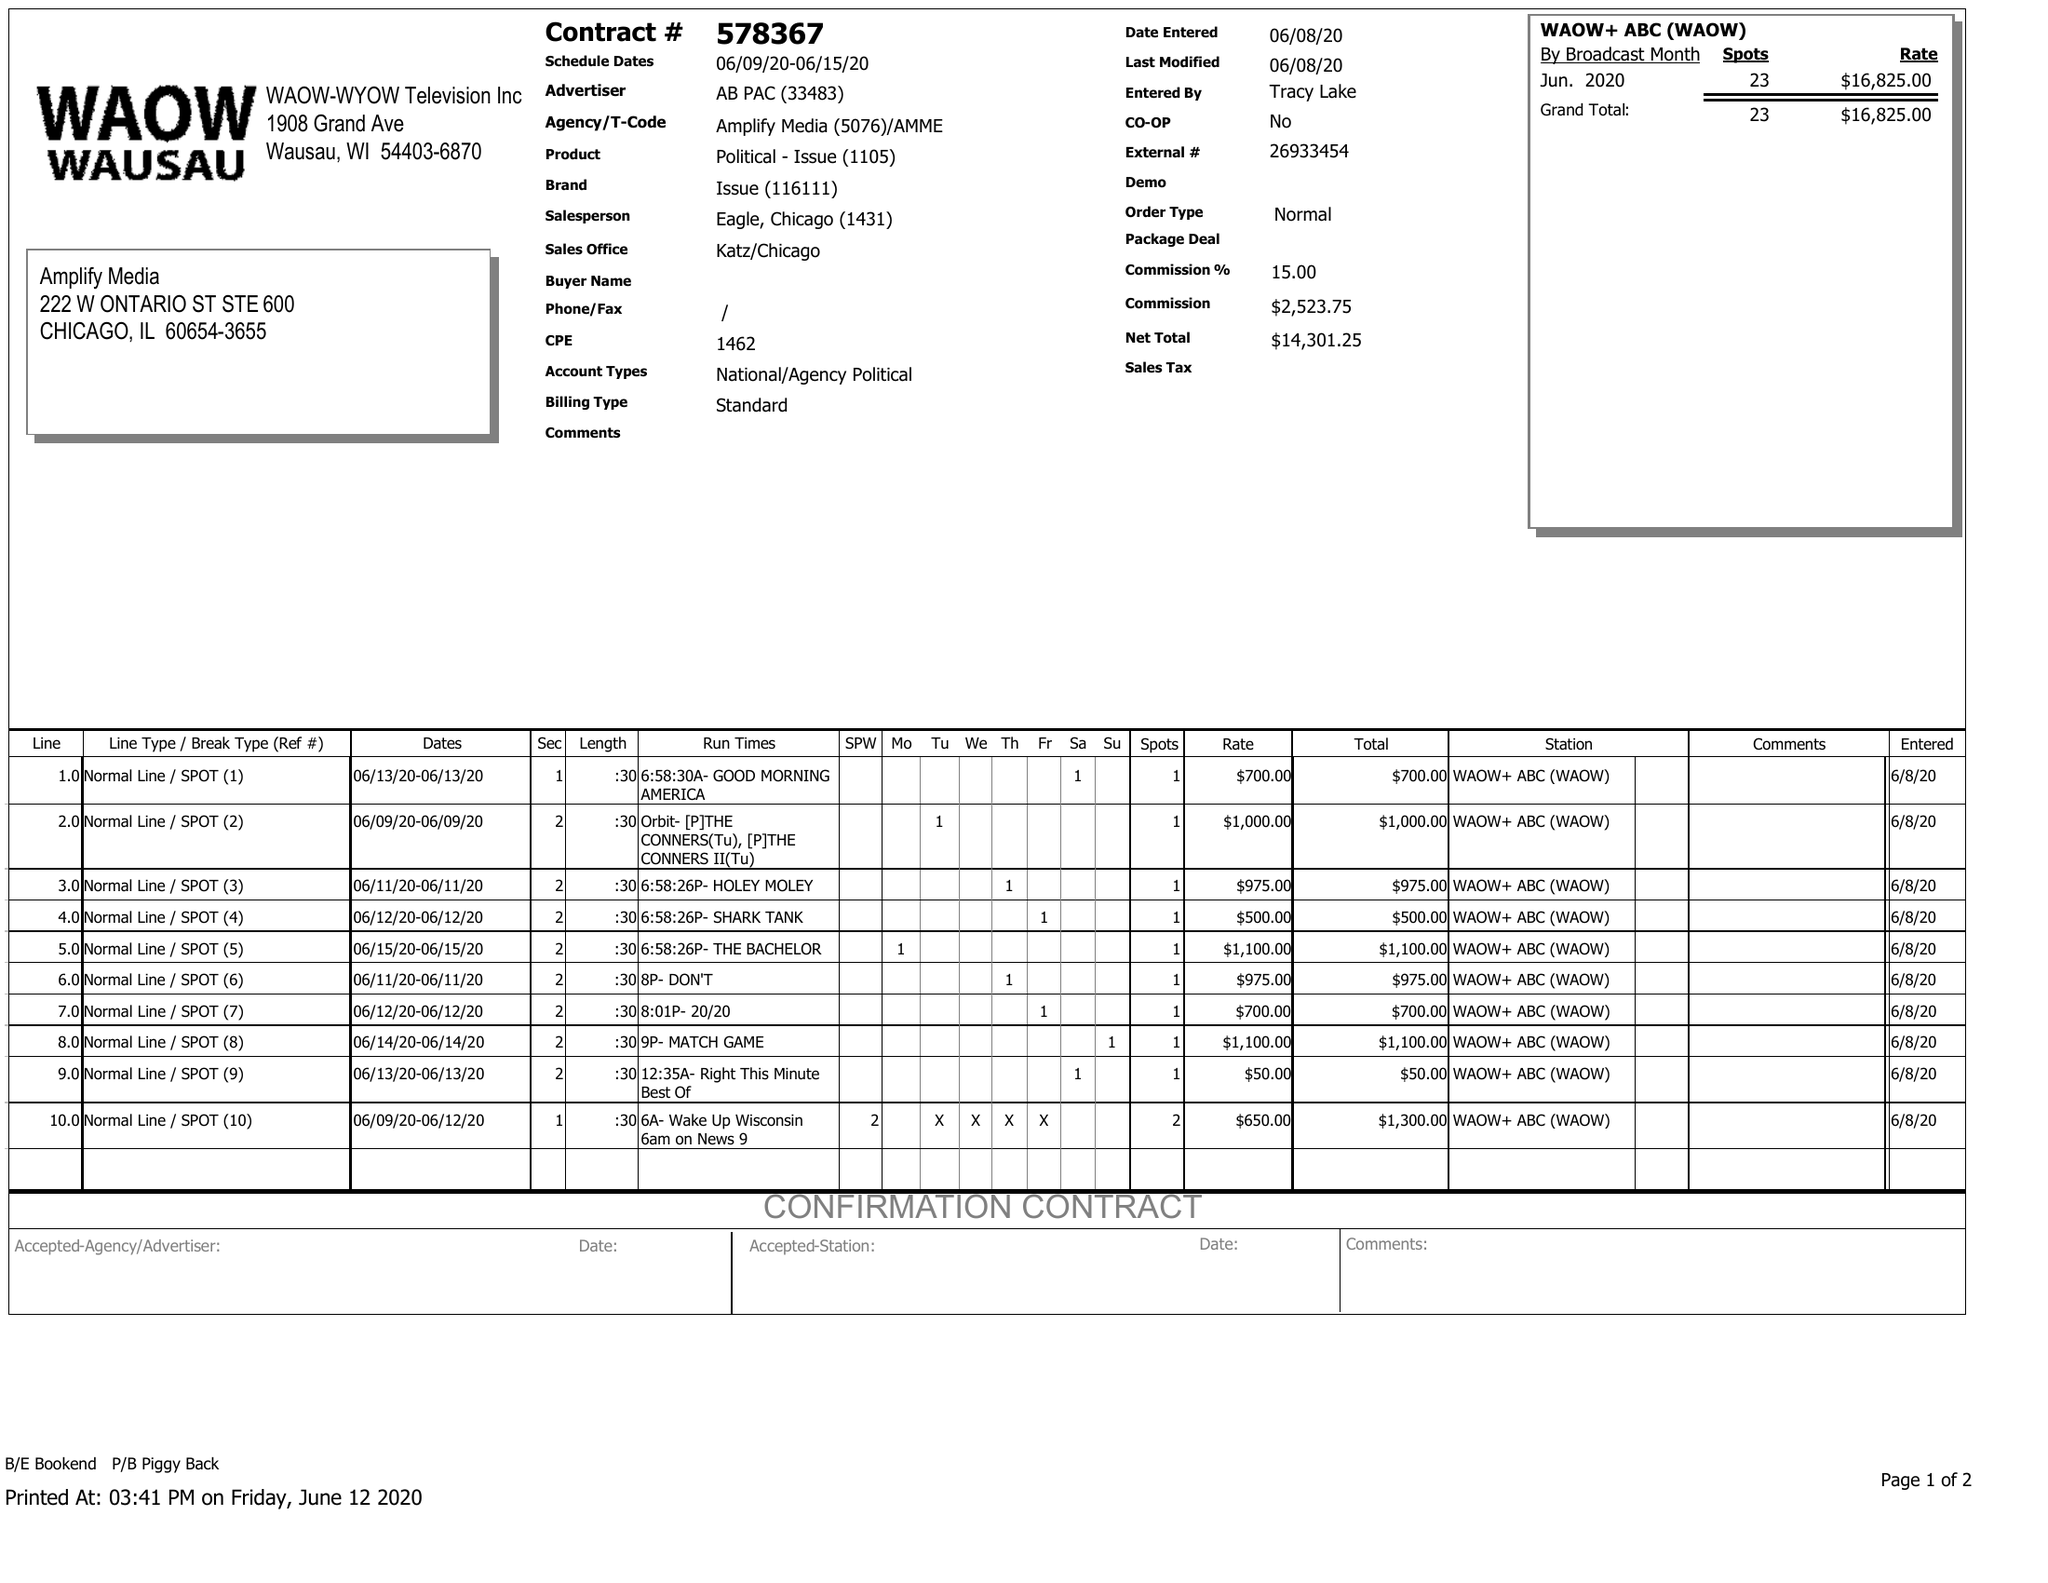What is the value for the flight_from?
Answer the question using a single word or phrase. 06/09/20 